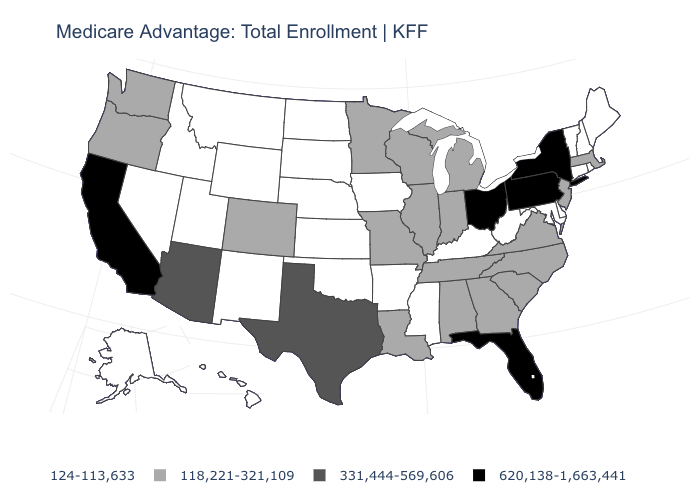What is the value of Connecticut?
Quick response, please. 124-113,633. What is the value of Tennessee?
Keep it brief. 118,221-321,109. Does Arkansas have the lowest value in the USA?
Be succinct. Yes. Does South Carolina have a higher value than Wisconsin?
Quick response, please. No. What is the value of Oklahoma?
Write a very short answer. 124-113,633. Does Maryland have a lower value than Alaska?
Concise answer only. No. Does California have the highest value in the USA?
Short answer required. Yes. Which states have the lowest value in the USA?
Keep it brief. Alaska, Arkansas, Connecticut, Delaware, Hawaii, Iowa, Idaho, Kansas, Kentucky, Maryland, Maine, Mississippi, Montana, North Dakota, Nebraska, New Hampshire, New Mexico, Nevada, Oklahoma, Rhode Island, South Dakota, Utah, Vermont, West Virginia, Wyoming. What is the highest value in the MidWest ?
Give a very brief answer. 620,138-1,663,441. Name the states that have a value in the range 118,221-321,109?
Quick response, please. Alabama, Colorado, Georgia, Illinois, Indiana, Louisiana, Massachusetts, Michigan, Minnesota, Missouri, North Carolina, New Jersey, Oregon, South Carolina, Tennessee, Virginia, Washington, Wisconsin. Does the map have missing data?
Answer briefly. No. Name the states that have a value in the range 118,221-321,109?
Answer briefly. Alabama, Colorado, Georgia, Illinois, Indiana, Louisiana, Massachusetts, Michigan, Minnesota, Missouri, North Carolina, New Jersey, Oregon, South Carolina, Tennessee, Virginia, Washington, Wisconsin. What is the value of New Jersey?
Keep it brief. 118,221-321,109. Among the states that border Nevada , which have the lowest value?
Short answer required. Idaho, Utah. Among the states that border Kansas , which have the lowest value?
Be succinct. Nebraska, Oklahoma. 